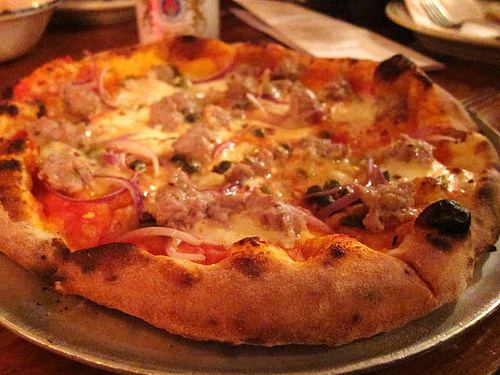Describe the objects in this image and their specific colors. I can see pizza in orange, red, brown, and maroon tones, cup in orange, salmon, and brown tones, bowl in orange, brown, red, and maroon tones, bowl in orange, maroon, black, brown, and tan tones, and fork in orange, tan, and brown tones in this image. 